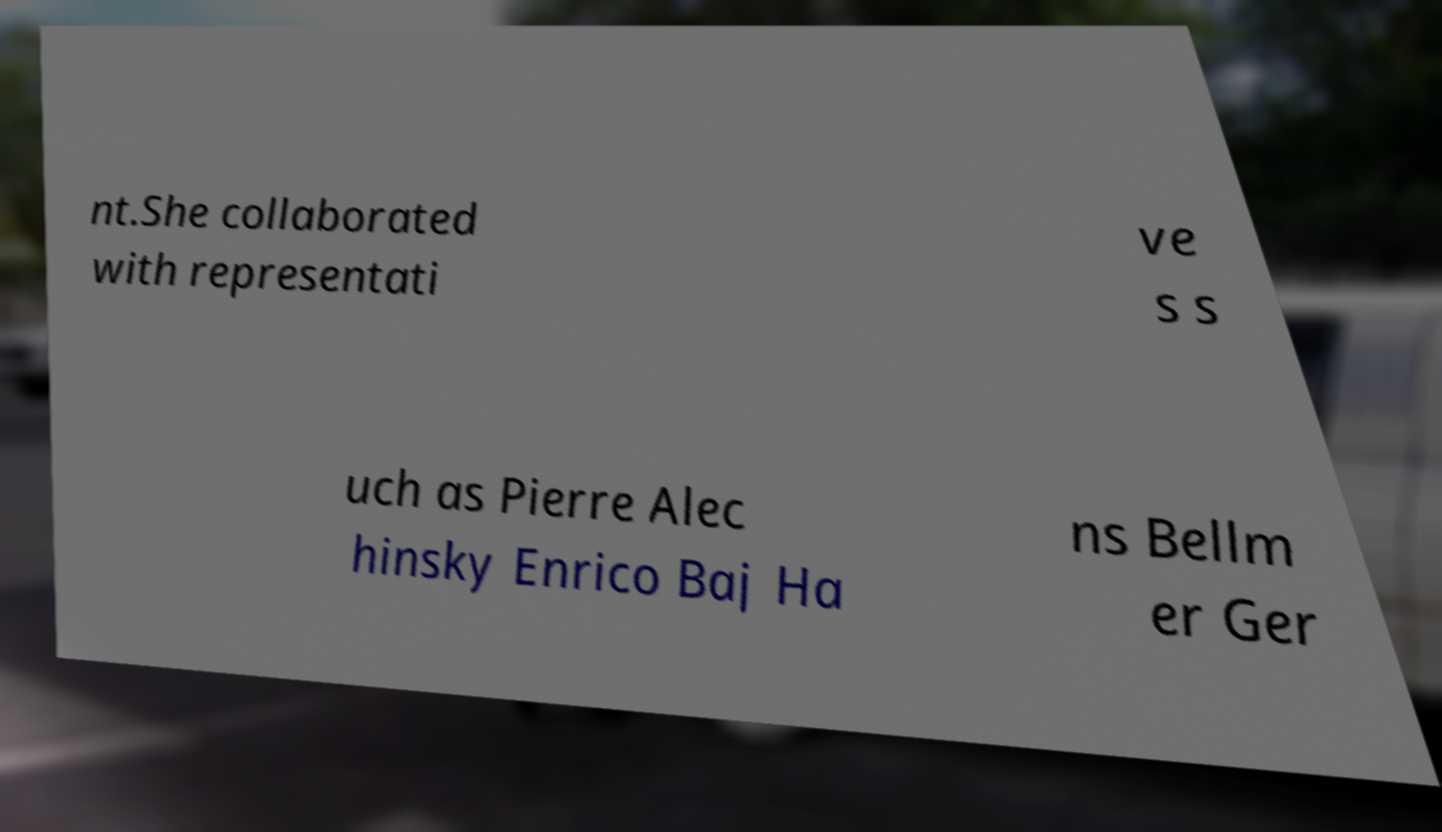Please identify and transcribe the text found in this image. nt.She collaborated with representati ve s s uch as Pierre Alec hinsky Enrico Baj Ha ns Bellm er Ger 